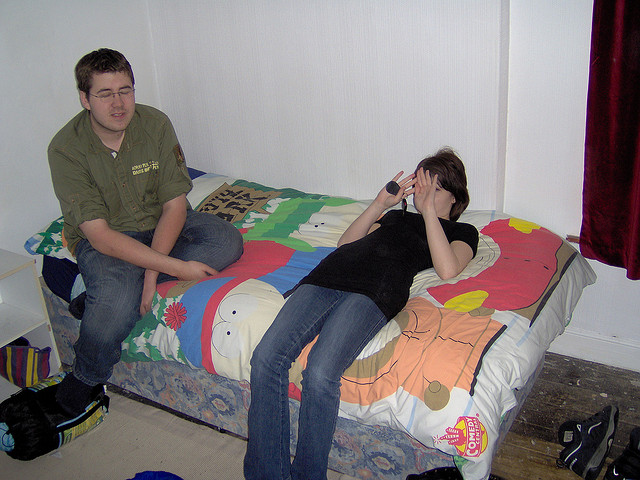Please extract the text content from this image. COMEDY 